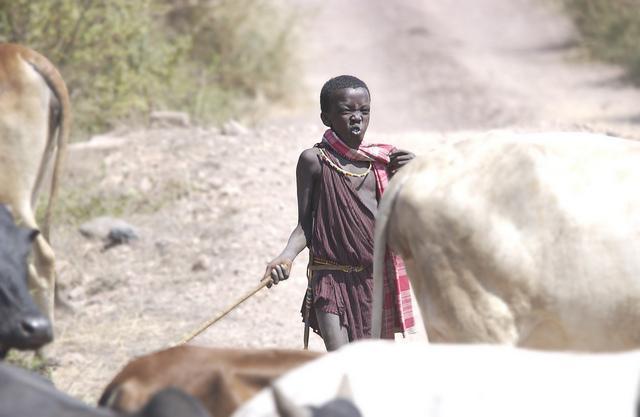What is this kid responsible for?
Answer the question by selecting the correct answer among the 4 following choices.
Options: Selling cows, punishing cows, herding cows, scaring cows. Herding cows. 